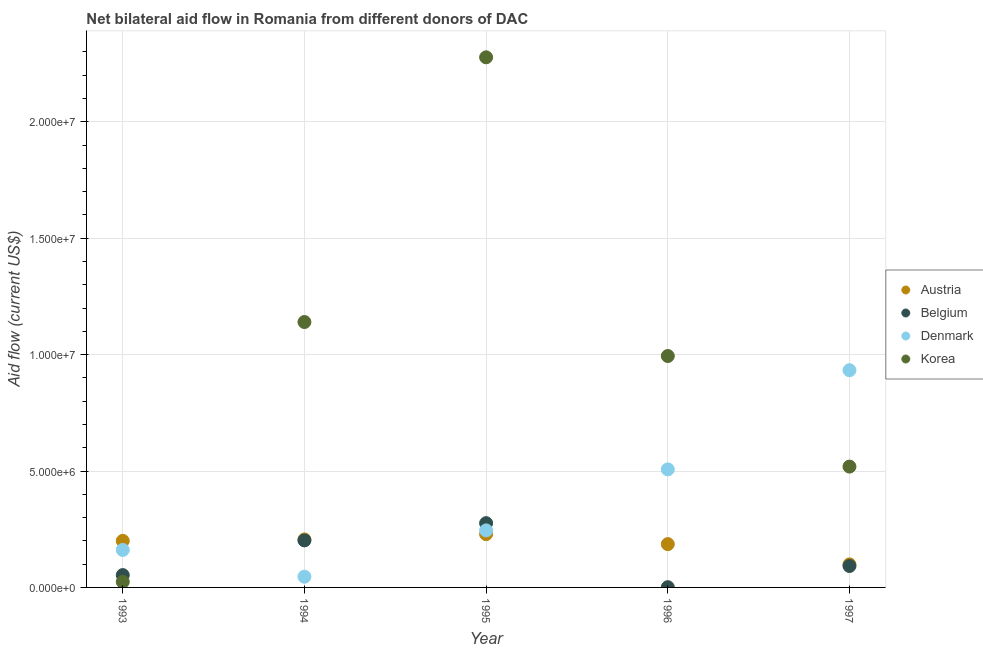What is the amount of aid given by denmark in 1996?
Your response must be concise. 5.07e+06. Across all years, what is the maximum amount of aid given by korea?
Your answer should be compact. 2.28e+07. Across all years, what is the minimum amount of aid given by denmark?
Ensure brevity in your answer.  4.60e+05. In which year was the amount of aid given by korea minimum?
Offer a very short reply. 1993. What is the total amount of aid given by denmark in the graph?
Provide a succinct answer. 1.89e+07. What is the difference between the amount of aid given by austria in 1993 and that in 1994?
Offer a very short reply. -6.00e+04. What is the difference between the amount of aid given by austria in 1993 and the amount of aid given by denmark in 1996?
Your answer should be very brief. -3.07e+06. What is the average amount of aid given by austria per year?
Provide a succinct answer. 1.84e+06. In the year 1994, what is the difference between the amount of aid given by denmark and amount of aid given by korea?
Keep it short and to the point. -1.09e+07. In how many years, is the amount of aid given by korea greater than 3000000 US$?
Your answer should be very brief. 4. What is the ratio of the amount of aid given by denmark in 1994 to that in 1996?
Provide a succinct answer. 0.09. Is the difference between the amount of aid given by korea in 1993 and 1997 greater than the difference between the amount of aid given by austria in 1993 and 1997?
Ensure brevity in your answer.  No. What is the difference between the highest and the second highest amount of aid given by austria?
Your answer should be very brief. 2.30e+05. What is the difference between the highest and the lowest amount of aid given by korea?
Your answer should be very brief. 2.25e+07. Is it the case that in every year, the sum of the amount of aid given by austria and amount of aid given by belgium is greater than the amount of aid given by denmark?
Give a very brief answer. No. Does the amount of aid given by korea monotonically increase over the years?
Keep it short and to the point. No. Is the amount of aid given by austria strictly less than the amount of aid given by denmark over the years?
Give a very brief answer. No. How many years are there in the graph?
Give a very brief answer. 5. What is the difference between two consecutive major ticks on the Y-axis?
Ensure brevity in your answer.  5.00e+06. How many legend labels are there?
Your answer should be compact. 4. What is the title of the graph?
Provide a succinct answer. Net bilateral aid flow in Romania from different donors of DAC. What is the label or title of the X-axis?
Your answer should be compact. Year. What is the label or title of the Y-axis?
Provide a succinct answer. Aid flow (current US$). What is the Aid flow (current US$) of Austria in 1993?
Make the answer very short. 2.00e+06. What is the Aid flow (current US$) in Belgium in 1993?
Offer a terse response. 5.30e+05. What is the Aid flow (current US$) of Denmark in 1993?
Your answer should be compact. 1.61e+06. What is the Aid flow (current US$) in Austria in 1994?
Provide a succinct answer. 2.06e+06. What is the Aid flow (current US$) of Belgium in 1994?
Your answer should be very brief. 2.02e+06. What is the Aid flow (current US$) of Denmark in 1994?
Give a very brief answer. 4.60e+05. What is the Aid flow (current US$) in Korea in 1994?
Provide a succinct answer. 1.14e+07. What is the Aid flow (current US$) in Austria in 1995?
Your answer should be compact. 2.29e+06. What is the Aid flow (current US$) of Belgium in 1995?
Keep it short and to the point. 2.76e+06. What is the Aid flow (current US$) in Denmark in 1995?
Ensure brevity in your answer.  2.45e+06. What is the Aid flow (current US$) of Korea in 1995?
Your answer should be compact. 2.28e+07. What is the Aid flow (current US$) in Austria in 1996?
Offer a terse response. 1.86e+06. What is the Aid flow (current US$) of Belgium in 1996?
Offer a terse response. 10000. What is the Aid flow (current US$) in Denmark in 1996?
Your answer should be very brief. 5.07e+06. What is the Aid flow (current US$) of Korea in 1996?
Provide a succinct answer. 9.94e+06. What is the Aid flow (current US$) in Austria in 1997?
Keep it short and to the point. 9.90e+05. What is the Aid flow (current US$) in Belgium in 1997?
Give a very brief answer. 9.20e+05. What is the Aid flow (current US$) in Denmark in 1997?
Offer a very short reply. 9.33e+06. What is the Aid flow (current US$) in Korea in 1997?
Ensure brevity in your answer.  5.19e+06. Across all years, what is the maximum Aid flow (current US$) in Austria?
Give a very brief answer. 2.29e+06. Across all years, what is the maximum Aid flow (current US$) of Belgium?
Give a very brief answer. 2.76e+06. Across all years, what is the maximum Aid flow (current US$) in Denmark?
Keep it short and to the point. 9.33e+06. Across all years, what is the maximum Aid flow (current US$) of Korea?
Make the answer very short. 2.28e+07. Across all years, what is the minimum Aid flow (current US$) in Austria?
Your response must be concise. 9.90e+05. Across all years, what is the minimum Aid flow (current US$) in Belgium?
Make the answer very short. 10000. Across all years, what is the minimum Aid flow (current US$) of Denmark?
Provide a succinct answer. 4.60e+05. Across all years, what is the minimum Aid flow (current US$) of Korea?
Provide a succinct answer. 2.40e+05. What is the total Aid flow (current US$) in Austria in the graph?
Ensure brevity in your answer.  9.20e+06. What is the total Aid flow (current US$) of Belgium in the graph?
Offer a terse response. 6.24e+06. What is the total Aid flow (current US$) in Denmark in the graph?
Ensure brevity in your answer.  1.89e+07. What is the total Aid flow (current US$) of Korea in the graph?
Offer a very short reply. 4.95e+07. What is the difference between the Aid flow (current US$) in Belgium in 1993 and that in 1994?
Your answer should be compact. -1.49e+06. What is the difference between the Aid flow (current US$) of Denmark in 1993 and that in 1994?
Offer a terse response. 1.15e+06. What is the difference between the Aid flow (current US$) in Korea in 1993 and that in 1994?
Provide a succinct answer. -1.12e+07. What is the difference between the Aid flow (current US$) of Austria in 1993 and that in 1995?
Your answer should be very brief. -2.90e+05. What is the difference between the Aid flow (current US$) of Belgium in 1993 and that in 1995?
Your answer should be very brief. -2.23e+06. What is the difference between the Aid flow (current US$) of Denmark in 1993 and that in 1995?
Make the answer very short. -8.40e+05. What is the difference between the Aid flow (current US$) of Korea in 1993 and that in 1995?
Your answer should be very brief. -2.25e+07. What is the difference between the Aid flow (current US$) in Austria in 1993 and that in 1996?
Give a very brief answer. 1.40e+05. What is the difference between the Aid flow (current US$) in Belgium in 1993 and that in 1996?
Make the answer very short. 5.20e+05. What is the difference between the Aid flow (current US$) of Denmark in 1993 and that in 1996?
Give a very brief answer. -3.46e+06. What is the difference between the Aid flow (current US$) of Korea in 1993 and that in 1996?
Your answer should be compact. -9.70e+06. What is the difference between the Aid flow (current US$) in Austria in 1993 and that in 1997?
Keep it short and to the point. 1.01e+06. What is the difference between the Aid flow (current US$) in Belgium in 1993 and that in 1997?
Provide a short and direct response. -3.90e+05. What is the difference between the Aid flow (current US$) in Denmark in 1993 and that in 1997?
Offer a very short reply. -7.72e+06. What is the difference between the Aid flow (current US$) of Korea in 1993 and that in 1997?
Offer a terse response. -4.95e+06. What is the difference between the Aid flow (current US$) in Belgium in 1994 and that in 1995?
Provide a short and direct response. -7.40e+05. What is the difference between the Aid flow (current US$) of Denmark in 1994 and that in 1995?
Keep it short and to the point. -1.99e+06. What is the difference between the Aid flow (current US$) in Korea in 1994 and that in 1995?
Offer a very short reply. -1.14e+07. What is the difference between the Aid flow (current US$) of Belgium in 1994 and that in 1996?
Offer a very short reply. 2.01e+06. What is the difference between the Aid flow (current US$) in Denmark in 1994 and that in 1996?
Offer a very short reply. -4.61e+06. What is the difference between the Aid flow (current US$) of Korea in 1994 and that in 1996?
Ensure brevity in your answer.  1.46e+06. What is the difference between the Aid flow (current US$) of Austria in 1994 and that in 1997?
Your response must be concise. 1.07e+06. What is the difference between the Aid flow (current US$) in Belgium in 1994 and that in 1997?
Ensure brevity in your answer.  1.10e+06. What is the difference between the Aid flow (current US$) in Denmark in 1994 and that in 1997?
Provide a succinct answer. -8.87e+06. What is the difference between the Aid flow (current US$) in Korea in 1994 and that in 1997?
Ensure brevity in your answer.  6.21e+06. What is the difference between the Aid flow (current US$) of Belgium in 1995 and that in 1996?
Your response must be concise. 2.75e+06. What is the difference between the Aid flow (current US$) of Denmark in 1995 and that in 1996?
Provide a short and direct response. -2.62e+06. What is the difference between the Aid flow (current US$) in Korea in 1995 and that in 1996?
Provide a succinct answer. 1.28e+07. What is the difference between the Aid flow (current US$) in Austria in 1995 and that in 1997?
Your answer should be compact. 1.30e+06. What is the difference between the Aid flow (current US$) in Belgium in 1995 and that in 1997?
Offer a terse response. 1.84e+06. What is the difference between the Aid flow (current US$) in Denmark in 1995 and that in 1997?
Your response must be concise. -6.88e+06. What is the difference between the Aid flow (current US$) of Korea in 1995 and that in 1997?
Provide a short and direct response. 1.76e+07. What is the difference between the Aid flow (current US$) in Austria in 1996 and that in 1997?
Your answer should be compact. 8.70e+05. What is the difference between the Aid flow (current US$) of Belgium in 1996 and that in 1997?
Give a very brief answer. -9.10e+05. What is the difference between the Aid flow (current US$) of Denmark in 1996 and that in 1997?
Your answer should be very brief. -4.26e+06. What is the difference between the Aid flow (current US$) in Korea in 1996 and that in 1997?
Keep it short and to the point. 4.75e+06. What is the difference between the Aid flow (current US$) of Austria in 1993 and the Aid flow (current US$) of Denmark in 1994?
Your response must be concise. 1.54e+06. What is the difference between the Aid flow (current US$) of Austria in 1993 and the Aid flow (current US$) of Korea in 1994?
Offer a terse response. -9.40e+06. What is the difference between the Aid flow (current US$) of Belgium in 1993 and the Aid flow (current US$) of Denmark in 1994?
Your answer should be compact. 7.00e+04. What is the difference between the Aid flow (current US$) in Belgium in 1993 and the Aid flow (current US$) in Korea in 1994?
Give a very brief answer. -1.09e+07. What is the difference between the Aid flow (current US$) in Denmark in 1993 and the Aid flow (current US$) in Korea in 1994?
Make the answer very short. -9.79e+06. What is the difference between the Aid flow (current US$) in Austria in 1993 and the Aid flow (current US$) in Belgium in 1995?
Give a very brief answer. -7.60e+05. What is the difference between the Aid flow (current US$) in Austria in 1993 and the Aid flow (current US$) in Denmark in 1995?
Make the answer very short. -4.50e+05. What is the difference between the Aid flow (current US$) in Austria in 1993 and the Aid flow (current US$) in Korea in 1995?
Keep it short and to the point. -2.08e+07. What is the difference between the Aid flow (current US$) in Belgium in 1993 and the Aid flow (current US$) in Denmark in 1995?
Keep it short and to the point. -1.92e+06. What is the difference between the Aid flow (current US$) in Belgium in 1993 and the Aid flow (current US$) in Korea in 1995?
Your response must be concise. -2.22e+07. What is the difference between the Aid flow (current US$) in Denmark in 1993 and the Aid flow (current US$) in Korea in 1995?
Give a very brief answer. -2.12e+07. What is the difference between the Aid flow (current US$) in Austria in 1993 and the Aid flow (current US$) in Belgium in 1996?
Provide a short and direct response. 1.99e+06. What is the difference between the Aid flow (current US$) of Austria in 1993 and the Aid flow (current US$) of Denmark in 1996?
Your answer should be compact. -3.07e+06. What is the difference between the Aid flow (current US$) in Austria in 1993 and the Aid flow (current US$) in Korea in 1996?
Your answer should be compact. -7.94e+06. What is the difference between the Aid flow (current US$) in Belgium in 1993 and the Aid flow (current US$) in Denmark in 1996?
Give a very brief answer. -4.54e+06. What is the difference between the Aid flow (current US$) of Belgium in 1993 and the Aid flow (current US$) of Korea in 1996?
Your answer should be compact. -9.41e+06. What is the difference between the Aid flow (current US$) of Denmark in 1993 and the Aid flow (current US$) of Korea in 1996?
Your response must be concise. -8.33e+06. What is the difference between the Aid flow (current US$) of Austria in 1993 and the Aid flow (current US$) of Belgium in 1997?
Provide a short and direct response. 1.08e+06. What is the difference between the Aid flow (current US$) in Austria in 1993 and the Aid flow (current US$) in Denmark in 1997?
Offer a terse response. -7.33e+06. What is the difference between the Aid flow (current US$) of Austria in 1993 and the Aid flow (current US$) of Korea in 1997?
Keep it short and to the point. -3.19e+06. What is the difference between the Aid flow (current US$) in Belgium in 1993 and the Aid flow (current US$) in Denmark in 1997?
Offer a terse response. -8.80e+06. What is the difference between the Aid flow (current US$) of Belgium in 1993 and the Aid flow (current US$) of Korea in 1997?
Offer a very short reply. -4.66e+06. What is the difference between the Aid flow (current US$) in Denmark in 1993 and the Aid flow (current US$) in Korea in 1997?
Keep it short and to the point. -3.58e+06. What is the difference between the Aid flow (current US$) of Austria in 1994 and the Aid flow (current US$) of Belgium in 1995?
Give a very brief answer. -7.00e+05. What is the difference between the Aid flow (current US$) in Austria in 1994 and the Aid flow (current US$) in Denmark in 1995?
Provide a short and direct response. -3.90e+05. What is the difference between the Aid flow (current US$) of Austria in 1994 and the Aid flow (current US$) of Korea in 1995?
Make the answer very short. -2.07e+07. What is the difference between the Aid flow (current US$) in Belgium in 1994 and the Aid flow (current US$) in Denmark in 1995?
Make the answer very short. -4.30e+05. What is the difference between the Aid flow (current US$) of Belgium in 1994 and the Aid flow (current US$) of Korea in 1995?
Provide a succinct answer. -2.08e+07. What is the difference between the Aid flow (current US$) of Denmark in 1994 and the Aid flow (current US$) of Korea in 1995?
Provide a short and direct response. -2.23e+07. What is the difference between the Aid flow (current US$) of Austria in 1994 and the Aid flow (current US$) of Belgium in 1996?
Provide a succinct answer. 2.05e+06. What is the difference between the Aid flow (current US$) in Austria in 1994 and the Aid flow (current US$) in Denmark in 1996?
Give a very brief answer. -3.01e+06. What is the difference between the Aid flow (current US$) of Austria in 1994 and the Aid flow (current US$) of Korea in 1996?
Offer a very short reply. -7.88e+06. What is the difference between the Aid flow (current US$) in Belgium in 1994 and the Aid flow (current US$) in Denmark in 1996?
Make the answer very short. -3.05e+06. What is the difference between the Aid flow (current US$) of Belgium in 1994 and the Aid flow (current US$) of Korea in 1996?
Offer a terse response. -7.92e+06. What is the difference between the Aid flow (current US$) in Denmark in 1994 and the Aid flow (current US$) in Korea in 1996?
Make the answer very short. -9.48e+06. What is the difference between the Aid flow (current US$) of Austria in 1994 and the Aid flow (current US$) of Belgium in 1997?
Provide a short and direct response. 1.14e+06. What is the difference between the Aid flow (current US$) of Austria in 1994 and the Aid flow (current US$) of Denmark in 1997?
Offer a very short reply. -7.27e+06. What is the difference between the Aid flow (current US$) of Austria in 1994 and the Aid flow (current US$) of Korea in 1997?
Keep it short and to the point. -3.13e+06. What is the difference between the Aid flow (current US$) of Belgium in 1994 and the Aid flow (current US$) of Denmark in 1997?
Offer a terse response. -7.31e+06. What is the difference between the Aid flow (current US$) in Belgium in 1994 and the Aid flow (current US$) in Korea in 1997?
Ensure brevity in your answer.  -3.17e+06. What is the difference between the Aid flow (current US$) in Denmark in 1994 and the Aid flow (current US$) in Korea in 1997?
Make the answer very short. -4.73e+06. What is the difference between the Aid flow (current US$) in Austria in 1995 and the Aid flow (current US$) in Belgium in 1996?
Provide a short and direct response. 2.28e+06. What is the difference between the Aid flow (current US$) of Austria in 1995 and the Aid flow (current US$) of Denmark in 1996?
Make the answer very short. -2.78e+06. What is the difference between the Aid flow (current US$) in Austria in 1995 and the Aid flow (current US$) in Korea in 1996?
Offer a terse response. -7.65e+06. What is the difference between the Aid flow (current US$) of Belgium in 1995 and the Aid flow (current US$) of Denmark in 1996?
Your answer should be compact. -2.31e+06. What is the difference between the Aid flow (current US$) in Belgium in 1995 and the Aid flow (current US$) in Korea in 1996?
Make the answer very short. -7.18e+06. What is the difference between the Aid flow (current US$) of Denmark in 1995 and the Aid flow (current US$) of Korea in 1996?
Provide a short and direct response. -7.49e+06. What is the difference between the Aid flow (current US$) of Austria in 1995 and the Aid flow (current US$) of Belgium in 1997?
Your response must be concise. 1.37e+06. What is the difference between the Aid flow (current US$) in Austria in 1995 and the Aid flow (current US$) in Denmark in 1997?
Offer a terse response. -7.04e+06. What is the difference between the Aid flow (current US$) of Austria in 1995 and the Aid flow (current US$) of Korea in 1997?
Ensure brevity in your answer.  -2.90e+06. What is the difference between the Aid flow (current US$) of Belgium in 1995 and the Aid flow (current US$) of Denmark in 1997?
Provide a short and direct response. -6.57e+06. What is the difference between the Aid flow (current US$) of Belgium in 1995 and the Aid flow (current US$) of Korea in 1997?
Provide a short and direct response. -2.43e+06. What is the difference between the Aid flow (current US$) of Denmark in 1995 and the Aid flow (current US$) of Korea in 1997?
Provide a short and direct response. -2.74e+06. What is the difference between the Aid flow (current US$) of Austria in 1996 and the Aid flow (current US$) of Belgium in 1997?
Provide a short and direct response. 9.40e+05. What is the difference between the Aid flow (current US$) in Austria in 1996 and the Aid flow (current US$) in Denmark in 1997?
Your answer should be very brief. -7.47e+06. What is the difference between the Aid flow (current US$) in Austria in 1996 and the Aid flow (current US$) in Korea in 1997?
Ensure brevity in your answer.  -3.33e+06. What is the difference between the Aid flow (current US$) in Belgium in 1996 and the Aid flow (current US$) in Denmark in 1997?
Your response must be concise. -9.32e+06. What is the difference between the Aid flow (current US$) in Belgium in 1996 and the Aid flow (current US$) in Korea in 1997?
Offer a very short reply. -5.18e+06. What is the difference between the Aid flow (current US$) of Denmark in 1996 and the Aid flow (current US$) of Korea in 1997?
Give a very brief answer. -1.20e+05. What is the average Aid flow (current US$) of Austria per year?
Give a very brief answer. 1.84e+06. What is the average Aid flow (current US$) in Belgium per year?
Your response must be concise. 1.25e+06. What is the average Aid flow (current US$) of Denmark per year?
Your answer should be compact. 3.78e+06. What is the average Aid flow (current US$) in Korea per year?
Offer a very short reply. 9.91e+06. In the year 1993, what is the difference between the Aid flow (current US$) in Austria and Aid flow (current US$) in Belgium?
Offer a very short reply. 1.47e+06. In the year 1993, what is the difference between the Aid flow (current US$) in Austria and Aid flow (current US$) in Korea?
Offer a terse response. 1.76e+06. In the year 1993, what is the difference between the Aid flow (current US$) in Belgium and Aid flow (current US$) in Denmark?
Your response must be concise. -1.08e+06. In the year 1993, what is the difference between the Aid flow (current US$) in Denmark and Aid flow (current US$) in Korea?
Your answer should be compact. 1.37e+06. In the year 1994, what is the difference between the Aid flow (current US$) in Austria and Aid flow (current US$) in Denmark?
Your answer should be very brief. 1.60e+06. In the year 1994, what is the difference between the Aid flow (current US$) of Austria and Aid flow (current US$) of Korea?
Make the answer very short. -9.34e+06. In the year 1994, what is the difference between the Aid flow (current US$) in Belgium and Aid flow (current US$) in Denmark?
Make the answer very short. 1.56e+06. In the year 1994, what is the difference between the Aid flow (current US$) of Belgium and Aid flow (current US$) of Korea?
Provide a short and direct response. -9.38e+06. In the year 1994, what is the difference between the Aid flow (current US$) of Denmark and Aid flow (current US$) of Korea?
Your answer should be very brief. -1.09e+07. In the year 1995, what is the difference between the Aid flow (current US$) of Austria and Aid flow (current US$) of Belgium?
Offer a very short reply. -4.70e+05. In the year 1995, what is the difference between the Aid flow (current US$) in Austria and Aid flow (current US$) in Denmark?
Provide a succinct answer. -1.60e+05. In the year 1995, what is the difference between the Aid flow (current US$) of Austria and Aid flow (current US$) of Korea?
Give a very brief answer. -2.05e+07. In the year 1995, what is the difference between the Aid flow (current US$) of Belgium and Aid flow (current US$) of Denmark?
Your response must be concise. 3.10e+05. In the year 1995, what is the difference between the Aid flow (current US$) in Belgium and Aid flow (current US$) in Korea?
Provide a succinct answer. -2.00e+07. In the year 1995, what is the difference between the Aid flow (current US$) of Denmark and Aid flow (current US$) of Korea?
Your answer should be compact. -2.03e+07. In the year 1996, what is the difference between the Aid flow (current US$) of Austria and Aid flow (current US$) of Belgium?
Provide a short and direct response. 1.85e+06. In the year 1996, what is the difference between the Aid flow (current US$) in Austria and Aid flow (current US$) in Denmark?
Your answer should be very brief. -3.21e+06. In the year 1996, what is the difference between the Aid flow (current US$) in Austria and Aid flow (current US$) in Korea?
Offer a terse response. -8.08e+06. In the year 1996, what is the difference between the Aid flow (current US$) in Belgium and Aid flow (current US$) in Denmark?
Your answer should be very brief. -5.06e+06. In the year 1996, what is the difference between the Aid flow (current US$) of Belgium and Aid flow (current US$) of Korea?
Keep it short and to the point. -9.93e+06. In the year 1996, what is the difference between the Aid flow (current US$) of Denmark and Aid flow (current US$) of Korea?
Give a very brief answer. -4.87e+06. In the year 1997, what is the difference between the Aid flow (current US$) in Austria and Aid flow (current US$) in Belgium?
Offer a very short reply. 7.00e+04. In the year 1997, what is the difference between the Aid flow (current US$) in Austria and Aid flow (current US$) in Denmark?
Provide a succinct answer. -8.34e+06. In the year 1997, what is the difference between the Aid flow (current US$) of Austria and Aid flow (current US$) of Korea?
Give a very brief answer. -4.20e+06. In the year 1997, what is the difference between the Aid flow (current US$) in Belgium and Aid flow (current US$) in Denmark?
Keep it short and to the point. -8.41e+06. In the year 1997, what is the difference between the Aid flow (current US$) in Belgium and Aid flow (current US$) in Korea?
Give a very brief answer. -4.27e+06. In the year 1997, what is the difference between the Aid flow (current US$) of Denmark and Aid flow (current US$) of Korea?
Give a very brief answer. 4.14e+06. What is the ratio of the Aid flow (current US$) in Austria in 1993 to that in 1994?
Offer a very short reply. 0.97. What is the ratio of the Aid flow (current US$) in Belgium in 1993 to that in 1994?
Offer a very short reply. 0.26. What is the ratio of the Aid flow (current US$) of Denmark in 1993 to that in 1994?
Keep it short and to the point. 3.5. What is the ratio of the Aid flow (current US$) of Korea in 1993 to that in 1994?
Your answer should be compact. 0.02. What is the ratio of the Aid flow (current US$) in Austria in 1993 to that in 1995?
Provide a short and direct response. 0.87. What is the ratio of the Aid flow (current US$) of Belgium in 1993 to that in 1995?
Ensure brevity in your answer.  0.19. What is the ratio of the Aid flow (current US$) in Denmark in 1993 to that in 1995?
Provide a short and direct response. 0.66. What is the ratio of the Aid flow (current US$) in Korea in 1993 to that in 1995?
Your answer should be compact. 0.01. What is the ratio of the Aid flow (current US$) in Austria in 1993 to that in 1996?
Your answer should be very brief. 1.08. What is the ratio of the Aid flow (current US$) in Denmark in 1993 to that in 1996?
Provide a short and direct response. 0.32. What is the ratio of the Aid flow (current US$) of Korea in 1993 to that in 1996?
Offer a terse response. 0.02. What is the ratio of the Aid flow (current US$) in Austria in 1993 to that in 1997?
Offer a very short reply. 2.02. What is the ratio of the Aid flow (current US$) of Belgium in 1993 to that in 1997?
Your answer should be compact. 0.58. What is the ratio of the Aid flow (current US$) of Denmark in 1993 to that in 1997?
Provide a succinct answer. 0.17. What is the ratio of the Aid flow (current US$) of Korea in 1993 to that in 1997?
Ensure brevity in your answer.  0.05. What is the ratio of the Aid flow (current US$) in Austria in 1994 to that in 1995?
Keep it short and to the point. 0.9. What is the ratio of the Aid flow (current US$) in Belgium in 1994 to that in 1995?
Ensure brevity in your answer.  0.73. What is the ratio of the Aid flow (current US$) of Denmark in 1994 to that in 1995?
Ensure brevity in your answer.  0.19. What is the ratio of the Aid flow (current US$) in Korea in 1994 to that in 1995?
Provide a succinct answer. 0.5. What is the ratio of the Aid flow (current US$) in Austria in 1994 to that in 1996?
Your answer should be very brief. 1.11. What is the ratio of the Aid flow (current US$) in Belgium in 1994 to that in 1996?
Your response must be concise. 202. What is the ratio of the Aid flow (current US$) in Denmark in 1994 to that in 1996?
Keep it short and to the point. 0.09. What is the ratio of the Aid flow (current US$) of Korea in 1994 to that in 1996?
Give a very brief answer. 1.15. What is the ratio of the Aid flow (current US$) of Austria in 1994 to that in 1997?
Your answer should be very brief. 2.08. What is the ratio of the Aid flow (current US$) in Belgium in 1994 to that in 1997?
Provide a succinct answer. 2.2. What is the ratio of the Aid flow (current US$) in Denmark in 1994 to that in 1997?
Provide a short and direct response. 0.05. What is the ratio of the Aid flow (current US$) in Korea in 1994 to that in 1997?
Make the answer very short. 2.2. What is the ratio of the Aid flow (current US$) of Austria in 1995 to that in 1996?
Offer a very short reply. 1.23. What is the ratio of the Aid flow (current US$) of Belgium in 1995 to that in 1996?
Give a very brief answer. 276. What is the ratio of the Aid flow (current US$) of Denmark in 1995 to that in 1996?
Your response must be concise. 0.48. What is the ratio of the Aid flow (current US$) in Korea in 1995 to that in 1996?
Keep it short and to the point. 2.29. What is the ratio of the Aid flow (current US$) in Austria in 1995 to that in 1997?
Ensure brevity in your answer.  2.31. What is the ratio of the Aid flow (current US$) in Denmark in 1995 to that in 1997?
Give a very brief answer. 0.26. What is the ratio of the Aid flow (current US$) of Korea in 1995 to that in 1997?
Your answer should be compact. 4.39. What is the ratio of the Aid flow (current US$) of Austria in 1996 to that in 1997?
Keep it short and to the point. 1.88. What is the ratio of the Aid flow (current US$) in Belgium in 1996 to that in 1997?
Your answer should be compact. 0.01. What is the ratio of the Aid flow (current US$) of Denmark in 1996 to that in 1997?
Your answer should be compact. 0.54. What is the ratio of the Aid flow (current US$) of Korea in 1996 to that in 1997?
Offer a very short reply. 1.92. What is the difference between the highest and the second highest Aid flow (current US$) in Austria?
Give a very brief answer. 2.30e+05. What is the difference between the highest and the second highest Aid flow (current US$) of Belgium?
Keep it short and to the point. 7.40e+05. What is the difference between the highest and the second highest Aid flow (current US$) in Denmark?
Your answer should be compact. 4.26e+06. What is the difference between the highest and the second highest Aid flow (current US$) of Korea?
Provide a succinct answer. 1.14e+07. What is the difference between the highest and the lowest Aid flow (current US$) in Austria?
Your answer should be compact. 1.30e+06. What is the difference between the highest and the lowest Aid flow (current US$) of Belgium?
Give a very brief answer. 2.75e+06. What is the difference between the highest and the lowest Aid flow (current US$) in Denmark?
Make the answer very short. 8.87e+06. What is the difference between the highest and the lowest Aid flow (current US$) in Korea?
Your response must be concise. 2.25e+07. 